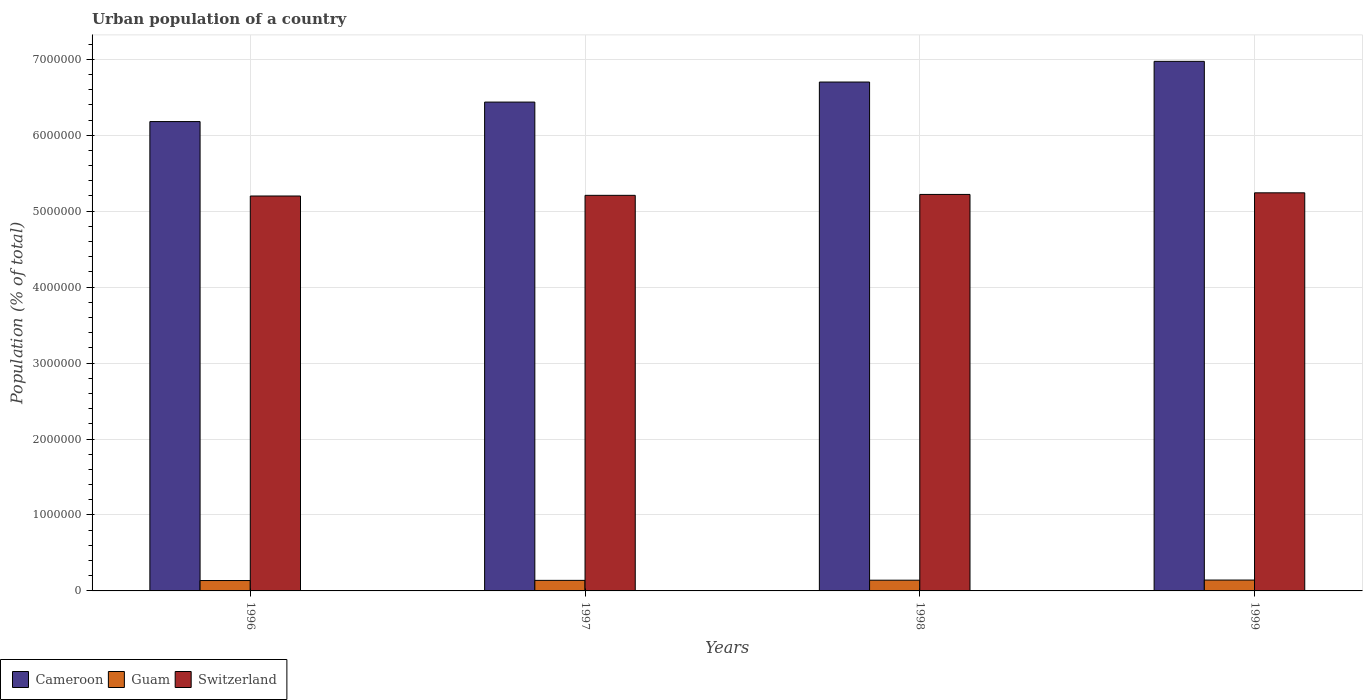Are the number of bars per tick equal to the number of legend labels?
Ensure brevity in your answer.  Yes. Are the number of bars on each tick of the X-axis equal?
Your answer should be compact. Yes. How many bars are there on the 2nd tick from the left?
Your answer should be compact. 3. What is the urban population in Cameroon in 1997?
Provide a short and direct response. 6.44e+06. Across all years, what is the maximum urban population in Guam?
Offer a terse response. 1.43e+05. Across all years, what is the minimum urban population in Switzerland?
Make the answer very short. 5.20e+06. In which year was the urban population in Cameroon minimum?
Provide a short and direct response. 1996. What is the total urban population in Guam in the graph?
Your answer should be compact. 5.60e+05. What is the difference between the urban population in Cameroon in 1996 and that in 1997?
Give a very brief answer. -2.56e+05. What is the difference between the urban population in Guam in 1999 and the urban population in Switzerland in 1996?
Offer a very short reply. -5.06e+06. What is the average urban population in Guam per year?
Keep it short and to the point. 1.40e+05. In the year 1999, what is the difference between the urban population in Switzerland and urban population in Guam?
Give a very brief answer. 5.10e+06. In how many years, is the urban population in Cameroon greater than 3400000 %?
Make the answer very short. 4. What is the ratio of the urban population in Cameroon in 1998 to that in 1999?
Your answer should be very brief. 0.96. What is the difference between the highest and the second highest urban population in Guam?
Your answer should be very brief. 1882. What is the difference between the highest and the lowest urban population in Switzerland?
Provide a short and direct response. 4.20e+04. In how many years, is the urban population in Cameroon greater than the average urban population in Cameroon taken over all years?
Provide a succinct answer. 2. Is the sum of the urban population in Guam in 1996 and 1997 greater than the maximum urban population in Switzerland across all years?
Provide a succinct answer. No. What does the 1st bar from the left in 1998 represents?
Provide a succinct answer. Cameroon. What does the 2nd bar from the right in 1998 represents?
Keep it short and to the point. Guam. Is it the case that in every year, the sum of the urban population in Cameroon and urban population in Guam is greater than the urban population in Switzerland?
Your answer should be compact. Yes. Are all the bars in the graph horizontal?
Your response must be concise. No. How many years are there in the graph?
Keep it short and to the point. 4. What is the difference between two consecutive major ticks on the Y-axis?
Keep it short and to the point. 1.00e+06. Are the values on the major ticks of Y-axis written in scientific E-notation?
Provide a short and direct response. No. Does the graph contain any zero values?
Your answer should be very brief. No. Where does the legend appear in the graph?
Provide a short and direct response. Bottom left. How are the legend labels stacked?
Provide a succinct answer. Horizontal. What is the title of the graph?
Offer a very short reply. Urban population of a country. Does "Tonga" appear as one of the legend labels in the graph?
Your answer should be very brief. No. What is the label or title of the Y-axis?
Provide a short and direct response. Population (% of total). What is the Population (% of total) in Cameroon in 1996?
Ensure brevity in your answer.  6.18e+06. What is the Population (% of total) in Guam in 1996?
Your answer should be very brief. 1.37e+05. What is the Population (% of total) in Switzerland in 1996?
Give a very brief answer. 5.20e+06. What is the Population (% of total) in Cameroon in 1997?
Offer a very short reply. 6.44e+06. What is the Population (% of total) of Guam in 1997?
Provide a short and direct response. 1.39e+05. What is the Population (% of total) in Switzerland in 1997?
Make the answer very short. 5.21e+06. What is the Population (% of total) in Cameroon in 1998?
Your response must be concise. 6.70e+06. What is the Population (% of total) of Guam in 1998?
Provide a succinct answer. 1.41e+05. What is the Population (% of total) of Switzerland in 1998?
Provide a succinct answer. 5.22e+06. What is the Population (% of total) of Cameroon in 1999?
Your answer should be compact. 6.97e+06. What is the Population (% of total) of Guam in 1999?
Your answer should be very brief. 1.43e+05. What is the Population (% of total) of Switzerland in 1999?
Your answer should be very brief. 5.24e+06. Across all years, what is the maximum Population (% of total) in Cameroon?
Your answer should be very brief. 6.97e+06. Across all years, what is the maximum Population (% of total) in Guam?
Your response must be concise. 1.43e+05. Across all years, what is the maximum Population (% of total) of Switzerland?
Your answer should be compact. 5.24e+06. Across all years, what is the minimum Population (% of total) of Cameroon?
Offer a very short reply. 6.18e+06. Across all years, what is the minimum Population (% of total) of Guam?
Give a very brief answer. 1.37e+05. Across all years, what is the minimum Population (% of total) in Switzerland?
Your answer should be very brief. 5.20e+06. What is the total Population (% of total) in Cameroon in the graph?
Make the answer very short. 2.63e+07. What is the total Population (% of total) in Guam in the graph?
Make the answer very short. 5.60e+05. What is the total Population (% of total) in Switzerland in the graph?
Ensure brevity in your answer.  2.09e+07. What is the difference between the Population (% of total) of Cameroon in 1996 and that in 1997?
Your answer should be compact. -2.56e+05. What is the difference between the Population (% of total) in Guam in 1996 and that in 1997?
Make the answer very short. -2413. What is the difference between the Population (% of total) in Switzerland in 1996 and that in 1997?
Offer a very short reply. -8926. What is the difference between the Population (% of total) in Cameroon in 1996 and that in 1998?
Offer a terse response. -5.21e+05. What is the difference between the Population (% of total) of Guam in 1996 and that in 1998?
Provide a succinct answer. -4569. What is the difference between the Population (% of total) of Switzerland in 1996 and that in 1998?
Offer a terse response. -2.07e+04. What is the difference between the Population (% of total) in Cameroon in 1996 and that in 1999?
Your answer should be very brief. -7.93e+05. What is the difference between the Population (% of total) of Guam in 1996 and that in 1999?
Give a very brief answer. -6451. What is the difference between the Population (% of total) in Switzerland in 1996 and that in 1999?
Offer a terse response. -4.20e+04. What is the difference between the Population (% of total) in Cameroon in 1997 and that in 1998?
Offer a very short reply. -2.64e+05. What is the difference between the Population (% of total) in Guam in 1997 and that in 1998?
Make the answer very short. -2156. What is the difference between the Population (% of total) in Switzerland in 1997 and that in 1998?
Your answer should be very brief. -1.18e+04. What is the difference between the Population (% of total) in Cameroon in 1997 and that in 1999?
Offer a very short reply. -5.36e+05. What is the difference between the Population (% of total) of Guam in 1997 and that in 1999?
Your answer should be very brief. -4038. What is the difference between the Population (% of total) in Switzerland in 1997 and that in 1999?
Give a very brief answer. -3.31e+04. What is the difference between the Population (% of total) in Cameroon in 1998 and that in 1999?
Make the answer very short. -2.72e+05. What is the difference between the Population (% of total) of Guam in 1998 and that in 1999?
Keep it short and to the point. -1882. What is the difference between the Population (% of total) of Switzerland in 1998 and that in 1999?
Your answer should be very brief. -2.13e+04. What is the difference between the Population (% of total) in Cameroon in 1996 and the Population (% of total) in Guam in 1997?
Make the answer very short. 6.04e+06. What is the difference between the Population (% of total) of Cameroon in 1996 and the Population (% of total) of Switzerland in 1997?
Make the answer very short. 9.71e+05. What is the difference between the Population (% of total) of Guam in 1996 and the Population (% of total) of Switzerland in 1997?
Offer a terse response. -5.07e+06. What is the difference between the Population (% of total) in Cameroon in 1996 and the Population (% of total) in Guam in 1998?
Give a very brief answer. 6.04e+06. What is the difference between the Population (% of total) of Cameroon in 1996 and the Population (% of total) of Switzerland in 1998?
Your answer should be very brief. 9.59e+05. What is the difference between the Population (% of total) of Guam in 1996 and the Population (% of total) of Switzerland in 1998?
Ensure brevity in your answer.  -5.08e+06. What is the difference between the Population (% of total) in Cameroon in 1996 and the Population (% of total) in Guam in 1999?
Offer a very short reply. 6.04e+06. What is the difference between the Population (% of total) in Cameroon in 1996 and the Population (% of total) in Switzerland in 1999?
Give a very brief answer. 9.38e+05. What is the difference between the Population (% of total) in Guam in 1996 and the Population (% of total) in Switzerland in 1999?
Keep it short and to the point. -5.11e+06. What is the difference between the Population (% of total) of Cameroon in 1997 and the Population (% of total) of Guam in 1998?
Give a very brief answer. 6.30e+06. What is the difference between the Population (% of total) in Cameroon in 1997 and the Population (% of total) in Switzerland in 1998?
Keep it short and to the point. 1.22e+06. What is the difference between the Population (% of total) in Guam in 1997 and the Population (% of total) in Switzerland in 1998?
Keep it short and to the point. -5.08e+06. What is the difference between the Population (% of total) of Cameroon in 1997 and the Population (% of total) of Guam in 1999?
Make the answer very short. 6.29e+06. What is the difference between the Population (% of total) in Cameroon in 1997 and the Population (% of total) in Switzerland in 1999?
Give a very brief answer. 1.19e+06. What is the difference between the Population (% of total) of Guam in 1997 and the Population (% of total) of Switzerland in 1999?
Ensure brevity in your answer.  -5.10e+06. What is the difference between the Population (% of total) in Cameroon in 1998 and the Population (% of total) in Guam in 1999?
Provide a succinct answer. 6.56e+06. What is the difference between the Population (% of total) in Cameroon in 1998 and the Population (% of total) in Switzerland in 1999?
Ensure brevity in your answer.  1.46e+06. What is the difference between the Population (% of total) in Guam in 1998 and the Population (% of total) in Switzerland in 1999?
Make the answer very short. -5.10e+06. What is the average Population (% of total) in Cameroon per year?
Offer a terse response. 6.57e+06. What is the average Population (% of total) in Guam per year?
Your response must be concise. 1.40e+05. What is the average Population (% of total) of Switzerland per year?
Provide a succinct answer. 5.22e+06. In the year 1996, what is the difference between the Population (% of total) of Cameroon and Population (% of total) of Guam?
Offer a very short reply. 6.04e+06. In the year 1996, what is the difference between the Population (% of total) of Cameroon and Population (% of total) of Switzerland?
Keep it short and to the point. 9.80e+05. In the year 1996, what is the difference between the Population (% of total) of Guam and Population (% of total) of Switzerland?
Give a very brief answer. -5.06e+06. In the year 1997, what is the difference between the Population (% of total) of Cameroon and Population (% of total) of Guam?
Keep it short and to the point. 6.30e+06. In the year 1997, what is the difference between the Population (% of total) of Cameroon and Population (% of total) of Switzerland?
Keep it short and to the point. 1.23e+06. In the year 1997, what is the difference between the Population (% of total) in Guam and Population (% of total) in Switzerland?
Provide a short and direct response. -5.07e+06. In the year 1998, what is the difference between the Population (% of total) of Cameroon and Population (% of total) of Guam?
Offer a very short reply. 6.56e+06. In the year 1998, what is the difference between the Population (% of total) in Cameroon and Population (% of total) in Switzerland?
Your answer should be very brief. 1.48e+06. In the year 1998, what is the difference between the Population (% of total) of Guam and Population (% of total) of Switzerland?
Keep it short and to the point. -5.08e+06. In the year 1999, what is the difference between the Population (% of total) of Cameroon and Population (% of total) of Guam?
Make the answer very short. 6.83e+06. In the year 1999, what is the difference between the Population (% of total) of Cameroon and Population (% of total) of Switzerland?
Offer a terse response. 1.73e+06. In the year 1999, what is the difference between the Population (% of total) in Guam and Population (% of total) in Switzerland?
Provide a short and direct response. -5.10e+06. What is the ratio of the Population (% of total) of Cameroon in 1996 to that in 1997?
Your answer should be very brief. 0.96. What is the ratio of the Population (% of total) in Guam in 1996 to that in 1997?
Make the answer very short. 0.98. What is the ratio of the Population (% of total) in Cameroon in 1996 to that in 1998?
Your answer should be very brief. 0.92. What is the ratio of the Population (% of total) of Guam in 1996 to that in 1998?
Give a very brief answer. 0.97. What is the ratio of the Population (% of total) in Cameroon in 1996 to that in 1999?
Your response must be concise. 0.89. What is the ratio of the Population (% of total) in Guam in 1996 to that in 1999?
Provide a short and direct response. 0.95. What is the ratio of the Population (% of total) of Cameroon in 1997 to that in 1998?
Your answer should be very brief. 0.96. What is the ratio of the Population (% of total) in Guam in 1997 to that in 1998?
Provide a short and direct response. 0.98. What is the ratio of the Population (% of total) in Cameroon in 1997 to that in 1999?
Provide a short and direct response. 0.92. What is the ratio of the Population (% of total) of Guam in 1997 to that in 1999?
Your answer should be very brief. 0.97. What is the ratio of the Population (% of total) of Cameroon in 1998 to that in 1999?
Offer a very short reply. 0.96. What is the difference between the highest and the second highest Population (% of total) of Cameroon?
Your answer should be very brief. 2.72e+05. What is the difference between the highest and the second highest Population (% of total) in Guam?
Keep it short and to the point. 1882. What is the difference between the highest and the second highest Population (% of total) in Switzerland?
Keep it short and to the point. 2.13e+04. What is the difference between the highest and the lowest Population (% of total) of Cameroon?
Keep it short and to the point. 7.93e+05. What is the difference between the highest and the lowest Population (% of total) of Guam?
Give a very brief answer. 6451. What is the difference between the highest and the lowest Population (% of total) in Switzerland?
Make the answer very short. 4.20e+04. 